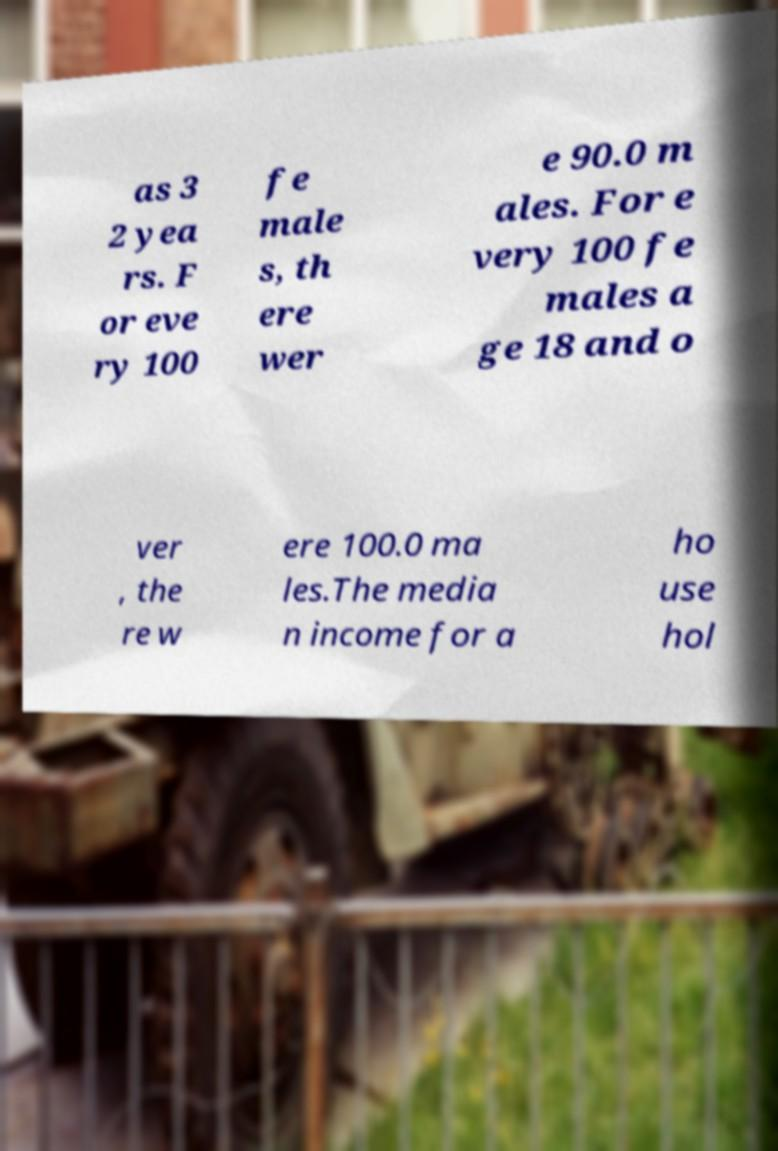I need the written content from this picture converted into text. Can you do that? as 3 2 yea rs. F or eve ry 100 fe male s, th ere wer e 90.0 m ales. For e very 100 fe males a ge 18 and o ver , the re w ere 100.0 ma les.The media n income for a ho use hol 